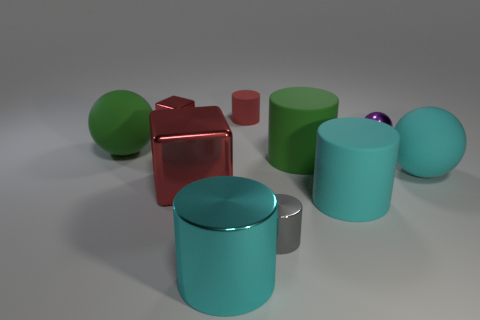Does the big block have the same color as the small metallic block?
Your answer should be very brief. Yes. Are there any other things of the same color as the metallic sphere?
Offer a very short reply. No. There is a small purple sphere; are there any matte spheres to the right of it?
Make the answer very short. Yes. What is the size of the green object on the right side of the small metal cube left of the tiny red rubber object?
Your response must be concise. Large. Are there an equal number of green cylinders in front of the large red metal block and large metallic blocks that are behind the green rubber cylinder?
Ensure brevity in your answer.  Yes. There is a tiny shiny thing in front of the green matte cylinder; is there a big green ball in front of it?
Ensure brevity in your answer.  No. There is a sphere on the left side of the big metallic block that is to the left of the tiny red rubber thing; what number of cyan rubber things are behind it?
Your answer should be compact. 0. Is the number of big cyan rubber balls less than the number of big gray matte objects?
Your response must be concise. No. Is the shape of the large green object that is right of the cyan metallic thing the same as the large matte thing on the left side of the small metallic cube?
Your answer should be very brief. No. The big cube has what color?
Your answer should be compact. Red. 